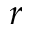<formula> <loc_0><loc_0><loc_500><loc_500>r</formula> 